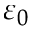<formula> <loc_0><loc_0><loc_500><loc_500>\varepsilon _ { 0 }</formula> 